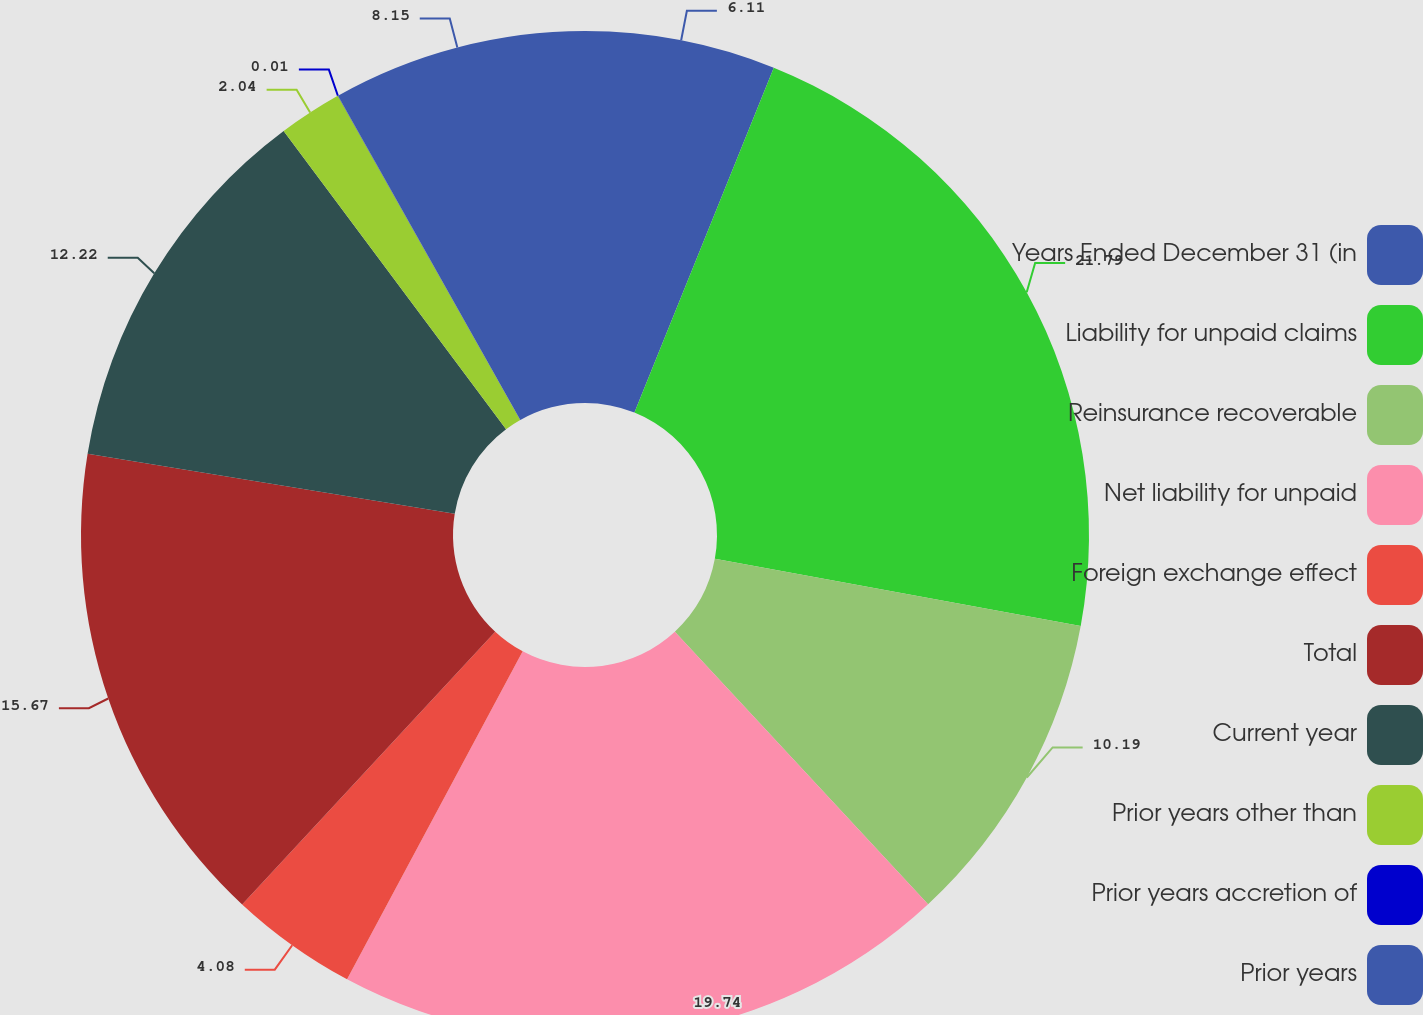Convert chart to OTSL. <chart><loc_0><loc_0><loc_500><loc_500><pie_chart><fcel>Years Ended December 31 (in<fcel>Liability for unpaid claims<fcel>Reinsurance recoverable<fcel>Net liability for unpaid<fcel>Foreign exchange effect<fcel>Total<fcel>Current year<fcel>Prior years other than<fcel>Prior years accretion of<fcel>Prior years<nl><fcel>6.11%<fcel>21.78%<fcel>10.19%<fcel>19.74%<fcel>4.08%<fcel>15.67%<fcel>12.22%<fcel>2.04%<fcel>0.01%<fcel>8.15%<nl></chart> 